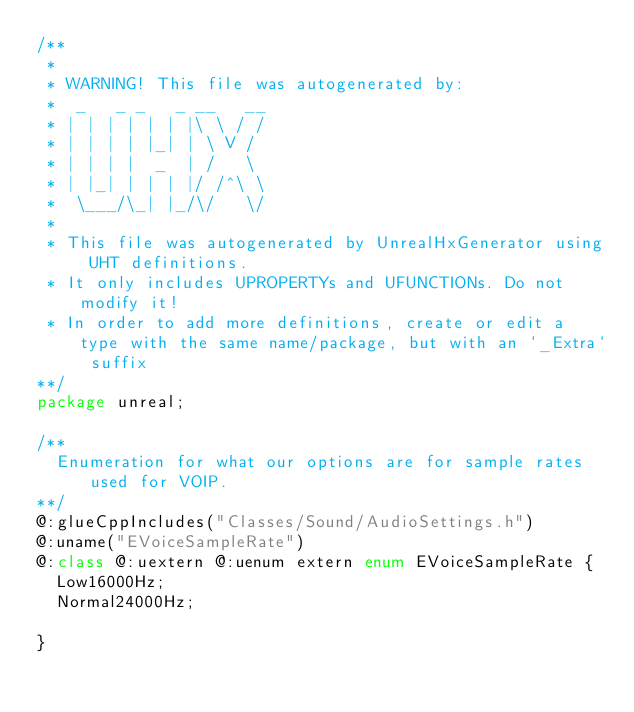<code> <loc_0><loc_0><loc_500><loc_500><_Haxe_>/**
 * 
 * WARNING! This file was autogenerated by: 
 *  _   _ _   _ __   __ 
 * | | | | | | |\ \ / / 
 * | | | | |_| | \ V /  
 * | | | |  _  | /   \  
 * | |_| | | | |/ /^\ \ 
 *  \___/\_| |_/\/   \/ 
 * 
 * This file was autogenerated by UnrealHxGenerator using UHT definitions.
 * It only includes UPROPERTYs and UFUNCTIONs. Do not modify it!
 * In order to add more definitions, create or edit a type with the same name/package, but with an `_Extra` suffix
**/
package unreal;

/**
  Enumeration for what our options are for sample rates used for VOIP.
**/
@:glueCppIncludes("Classes/Sound/AudioSettings.h")
@:uname("EVoiceSampleRate")
@:class @:uextern @:uenum extern enum EVoiceSampleRate {
  Low16000Hz;
  Normal24000Hz;
  
}
</code> 